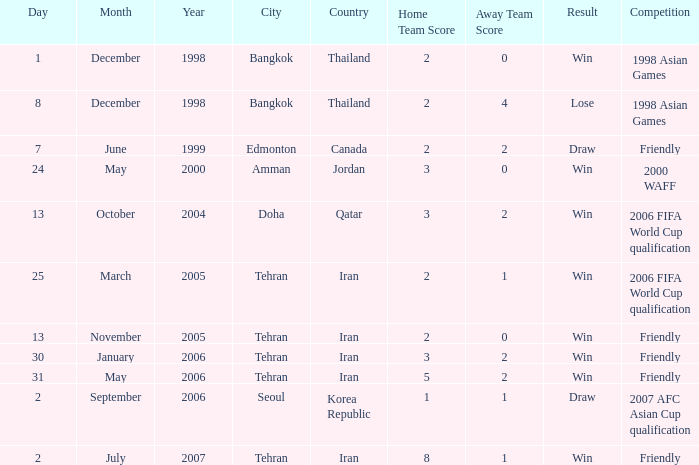I'm looking to parse the entire table for insights. Could you assist me with that? {'header': ['Day', 'Month', 'Year', 'City', 'Country', 'Home Team Score', 'Away Team Score', 'Result', 'Competition'], 'rows': [['1', 'December', '1998', 'Bangkok', 'Thailand', '2', '0', 'Win', '1998 Asian Games'], ['8', 'December', '1998', 'Bangkok', 'Thailand', '2', '4', 'Lose', '1998 Asian Games'], ['7', 'June', '1999', 'Edmonton', 'Canada', '2', '2', 'Draw', 'Friendly'], ['24', 'May', '2000', 'Amman', 'Jordan', '3', '0', 'Win', '2000 WAFF'], ['13', 'October', '2004', 'Doha', 'Qatar', '3', '2', 'Win', '2006 FIFA World Cup qualification'], ['25', 'March', '2005', 'Tehran', 'Iran', '2', '1', 'Win', '2006 FIFA World Cup qualification'], ['13', 'November', '2005', 'Tehran', 'Iran', '2', '0', 'Win', 'Friendly'], ['30', 'January', '2006', 'Tehran', 'Iran', '3', '2', 'Win', 'Friendly'], ['31', 'May', '2006', 'Tehran', 'Iran', '5', '2', 'Win', 'Friendly'], ['2', 'September', '2006', 'Seoul', 'Korea Republic', '1', '1', 'Draw', '2007 AFC Asian Cup qualification'], ['2', 'July', '2007', 'Tehran', 'Iran', '8', '1', 'Win', 'Friendly']]} Where was the friendly competition on 7 June 1999 played? Edmonton, Canada. 